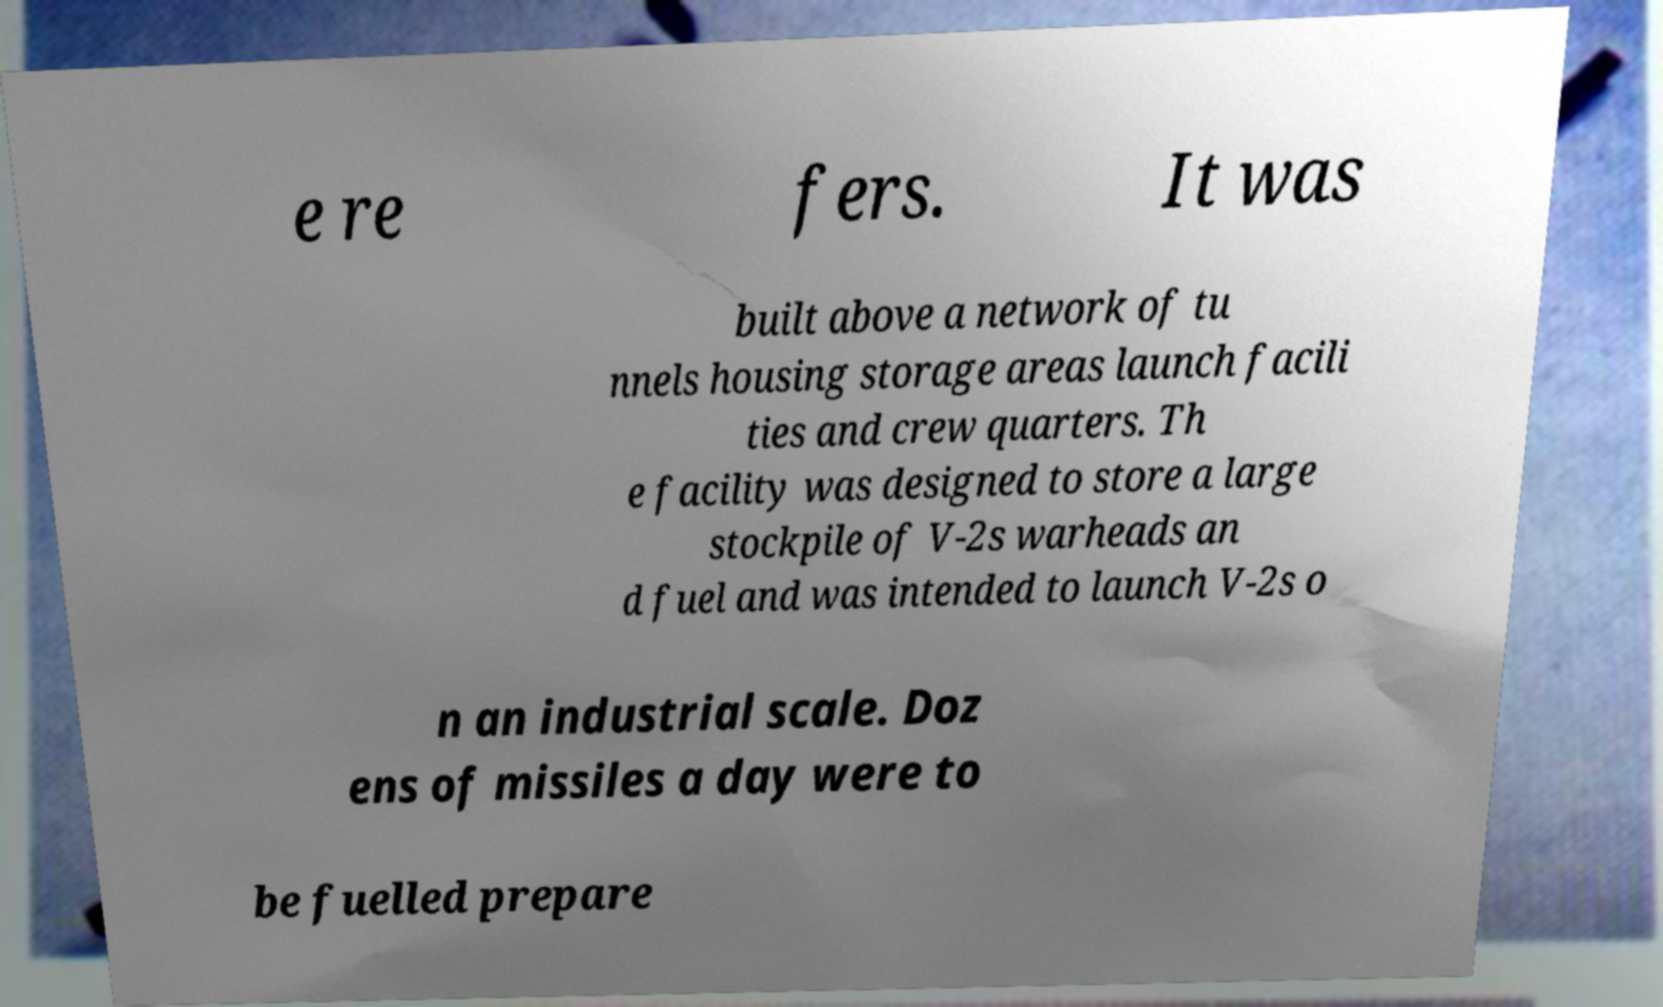There's text embedded in this image that I need extracted. Can you transcribe it verbatim? e re fers. It was built above a network of tu nnels housing storage areas launch facili ties and crew quarters. Th e facility was designed to store a large stockpile of V-2s warheads an d fuel and was intended to launch V-2s o n an industrial scale. Doz ens of missiles a day were to be fuelled prepare 